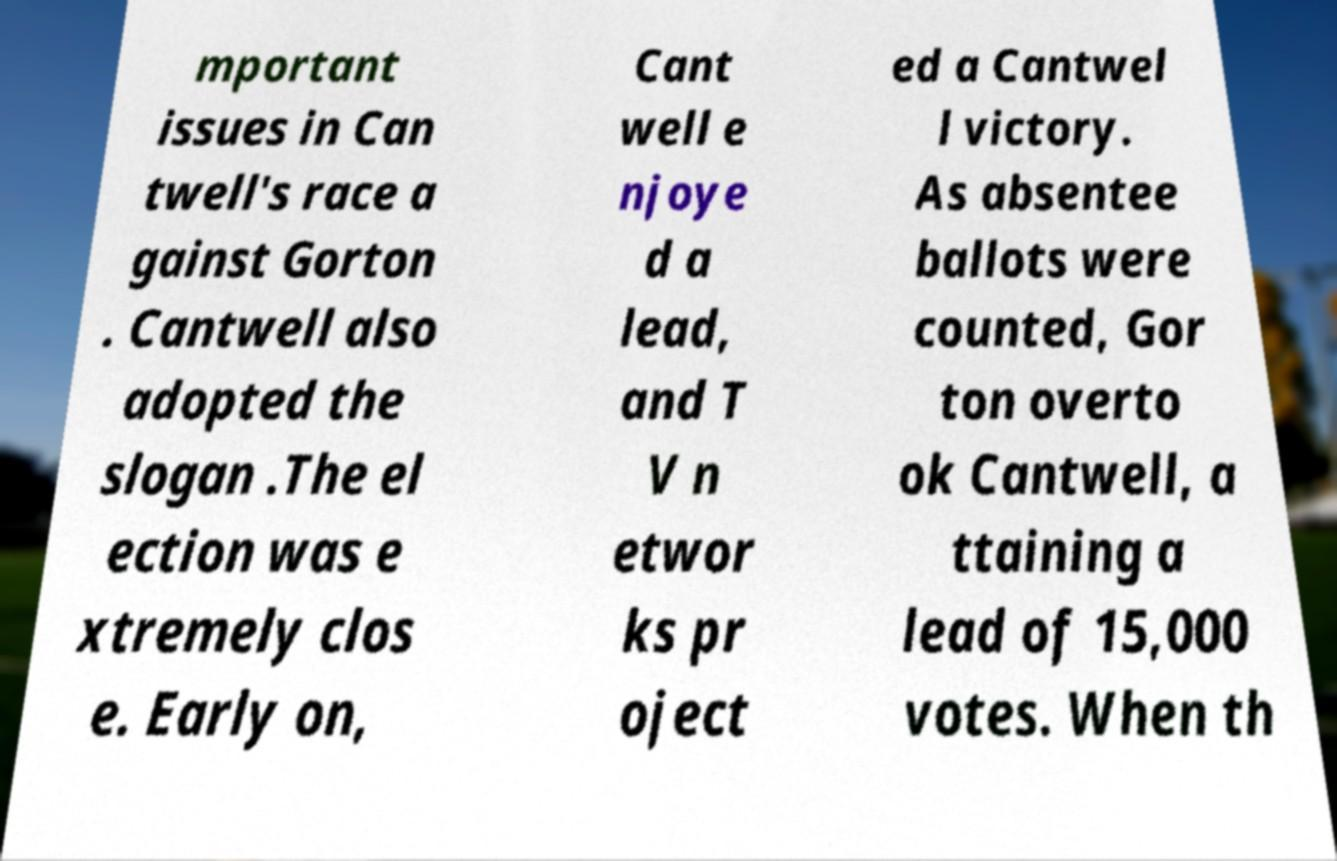What messages or text are displayed in this image? I need them in a readable, typed format. mportant issues in Can twell's race a gainst Gorton . Cantwell also adopted the slogan .The el ection was e xtremely clos e. Early on, Cant well e njoye d a lead, and T V n etwor ks pr oject ed a Cantwel l victory. As absentee ballots were counted, Gor ton overto ok Cantwell, a ttaining a lead of 15,000 votes. When th 